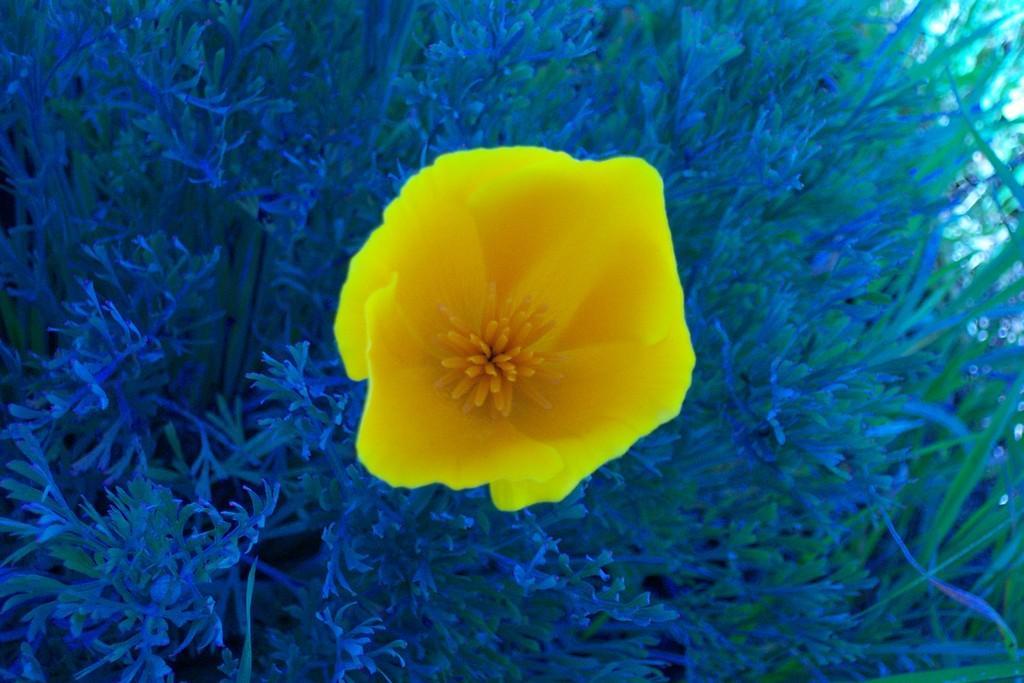Could you give a brief overview of what you see in this image? As we can see in the image there are plants and yellow color flower. 